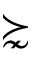Convert formula to latex. <formula><loc_0><loc_0><loc_500><loc_500>\succnsim</formula> 